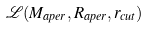<formula> <loc_0><loc_0><loc_500><loc_500>\mathcal { L } ( M _ { a p e r } , R _ { a p e r } , r _ { c u t } )</formula> 